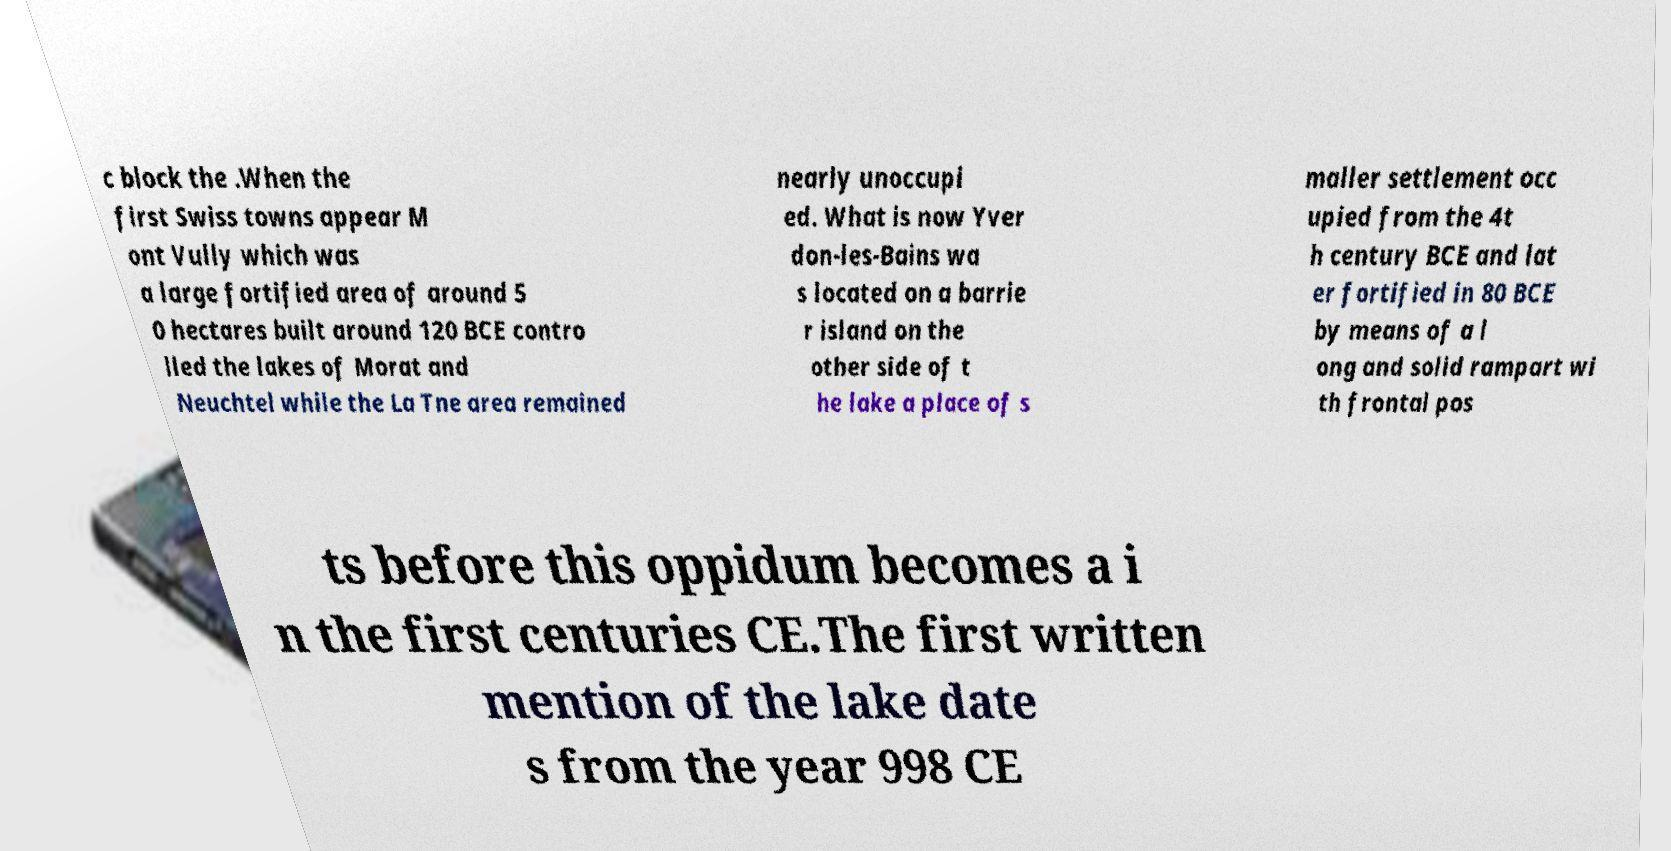Could you assist in decoding the text presented in this image and type it out clearly? c block the .When the first Swiss towns appear M ont Vully which was a large fortified area of around 5 0 hectares built around 120 BCE contro lled the lakes of Morat and Neuchtel while the La Tne area remained nearly unoccupi ed. What is now Yver don-les-Bains wa s located on a barrie r island on the other side of t he lake a place of s maller settlement occ upied from the 4t h century BCE and lat er fortified in 80 BCE by means of a l ong and solid rampart wi th frontal pos ts before this oppidum becomes a i n the first centuries CE.The first written mention of the lake date s from the year 998 CE 